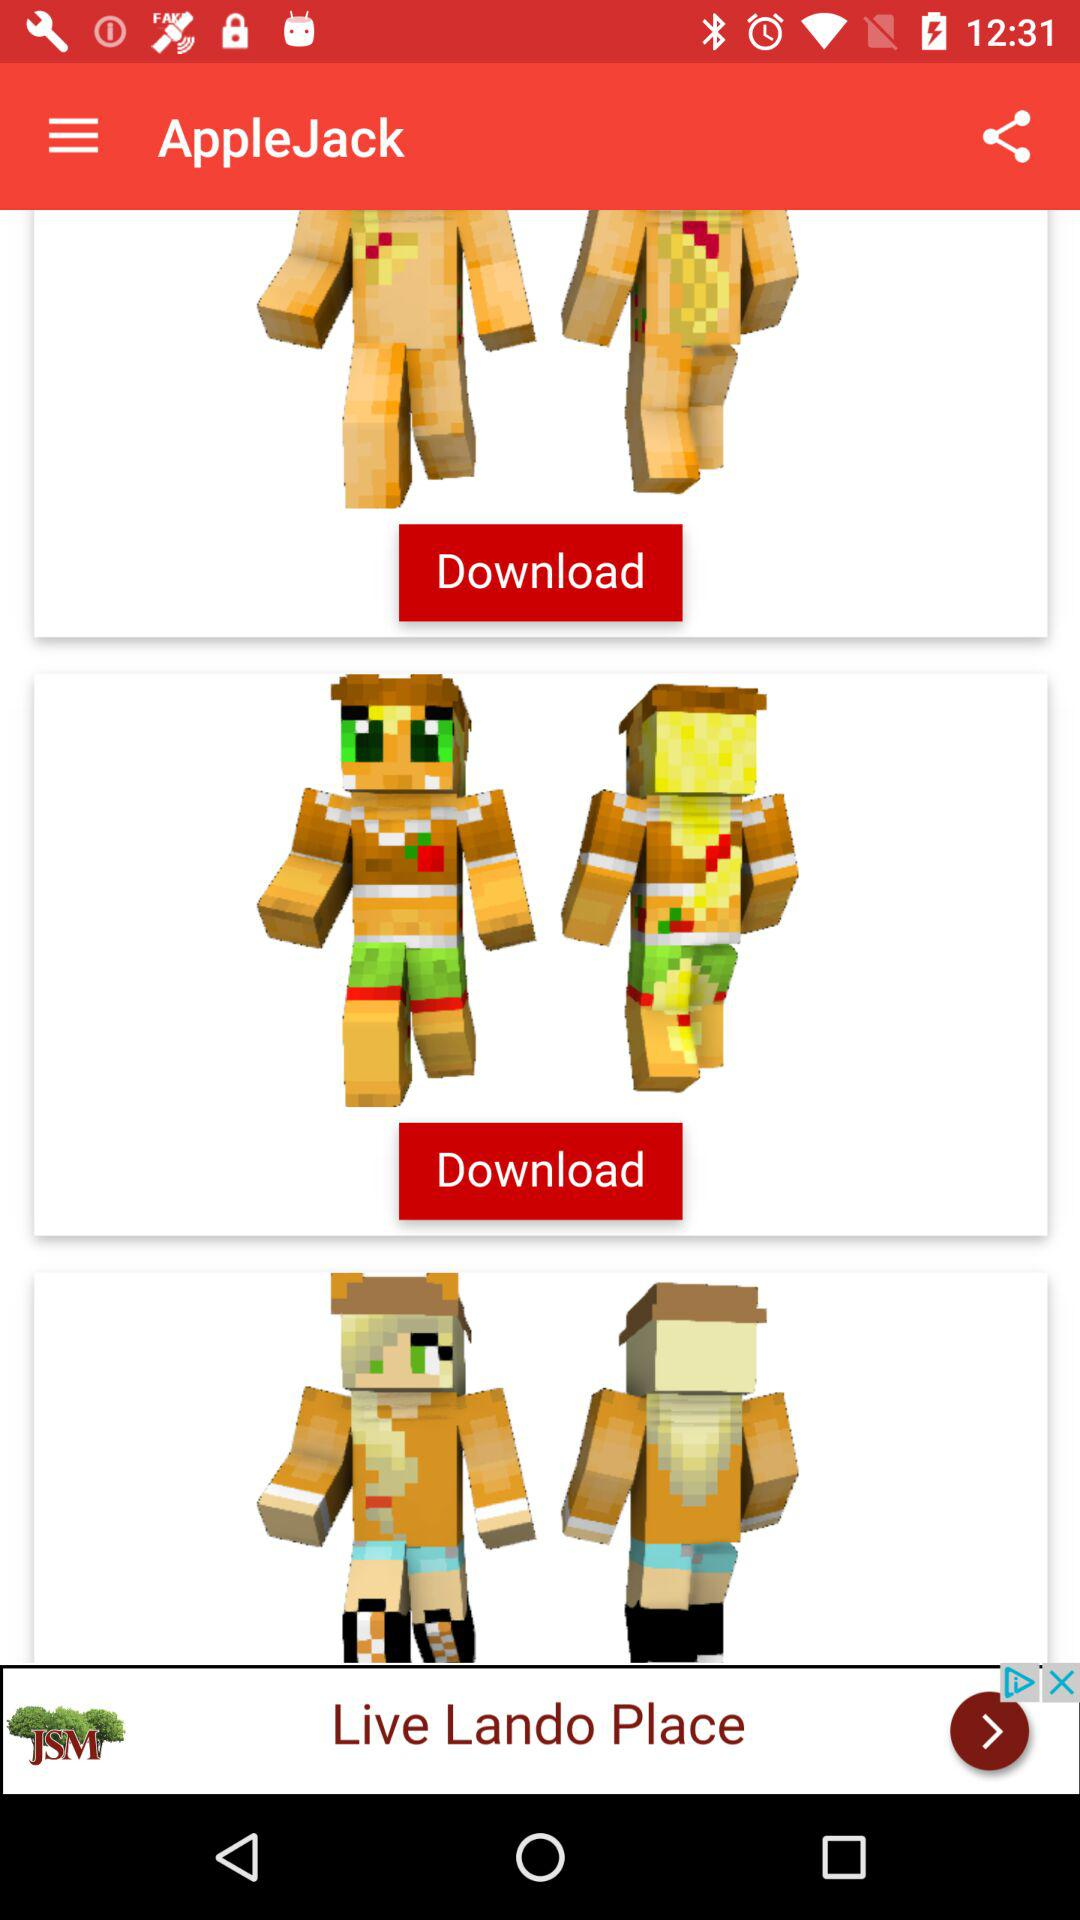What is the application name? The application name is "AppleJack". 